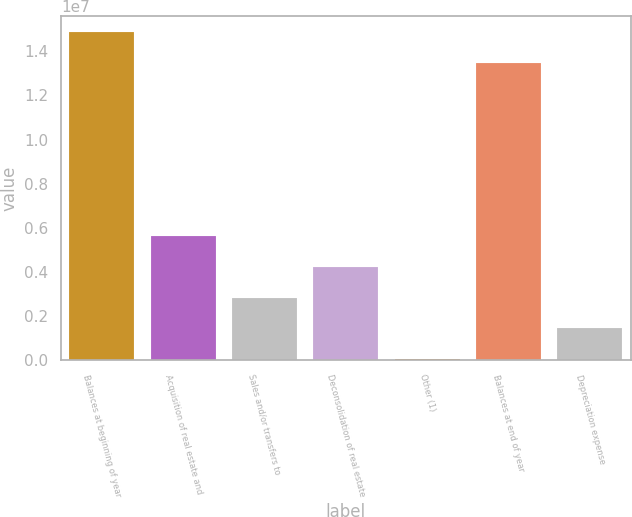Convert chart to OTSL. <chart><loc_0><loc_0><loc_500><loc_500><bar_chart><fcel>Balances at beginning of year<fcel>Acquisition of real estate and<fcel>Sales and/or transfers to<fcel>Deconsolidation of real estate<fcel>Other (1)<fcel>Balances at end of year<fcel>Depreciation expense<nl><fcel>1.48666e+07<fcel>5.61684e+06<fcel>2.83086e+06<fcel>4.22385e+06<fcel>44891<fcel>1.34736e+07<fcel>1.43788e+06<nl></chart> 